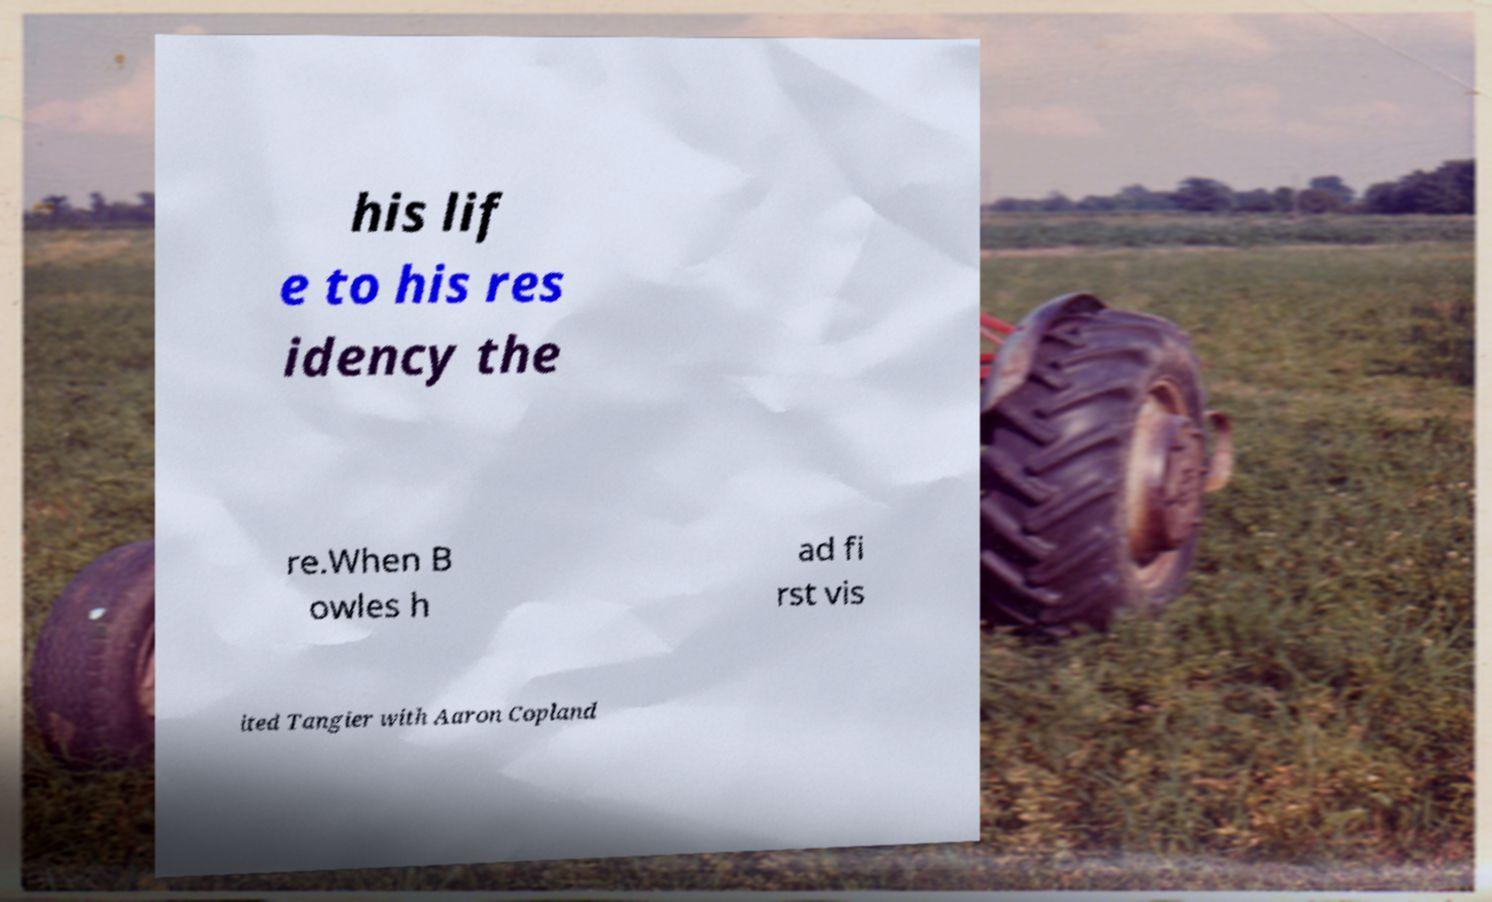For documentation purposes, I need the text within this image transcribed. Could you provide that? his lif e to his res idency the re.When B owles h ad fi rst vis ited Tangier with Aaron Copland 